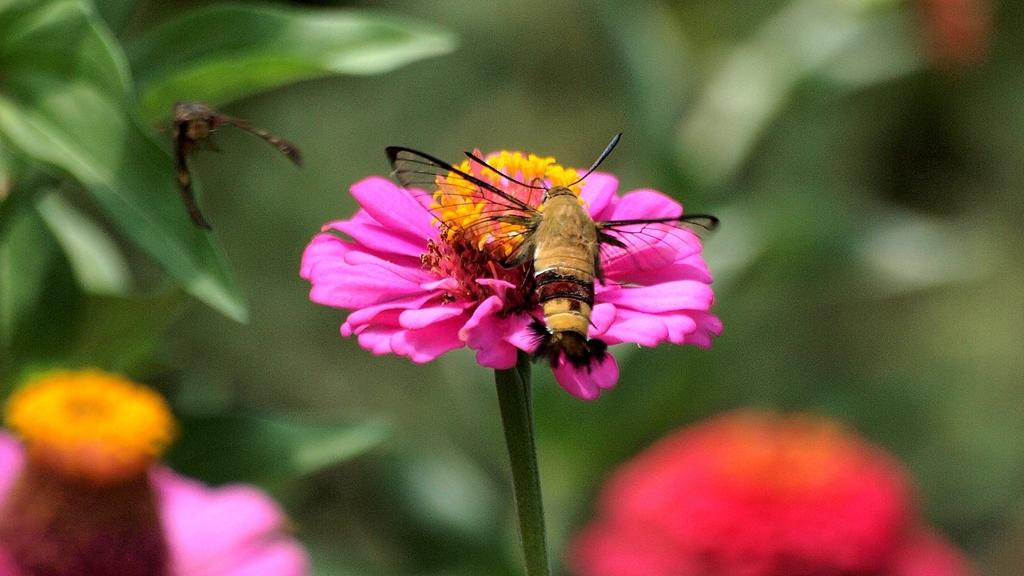What is the main subject in the foreground of the image? There is a fly on a flower in the foreground of the image. Are there any other flies visible in the image? Yes, there is another fly in the background of the image. What can be seen in the background of the image besides the second fly? There are flowers and leaves in the background of the image. What type of harbor can be seen in the background of the image? There is no harbor present in the image; it features a fly on a flower in the foreground and flowers and leaves in the background. 